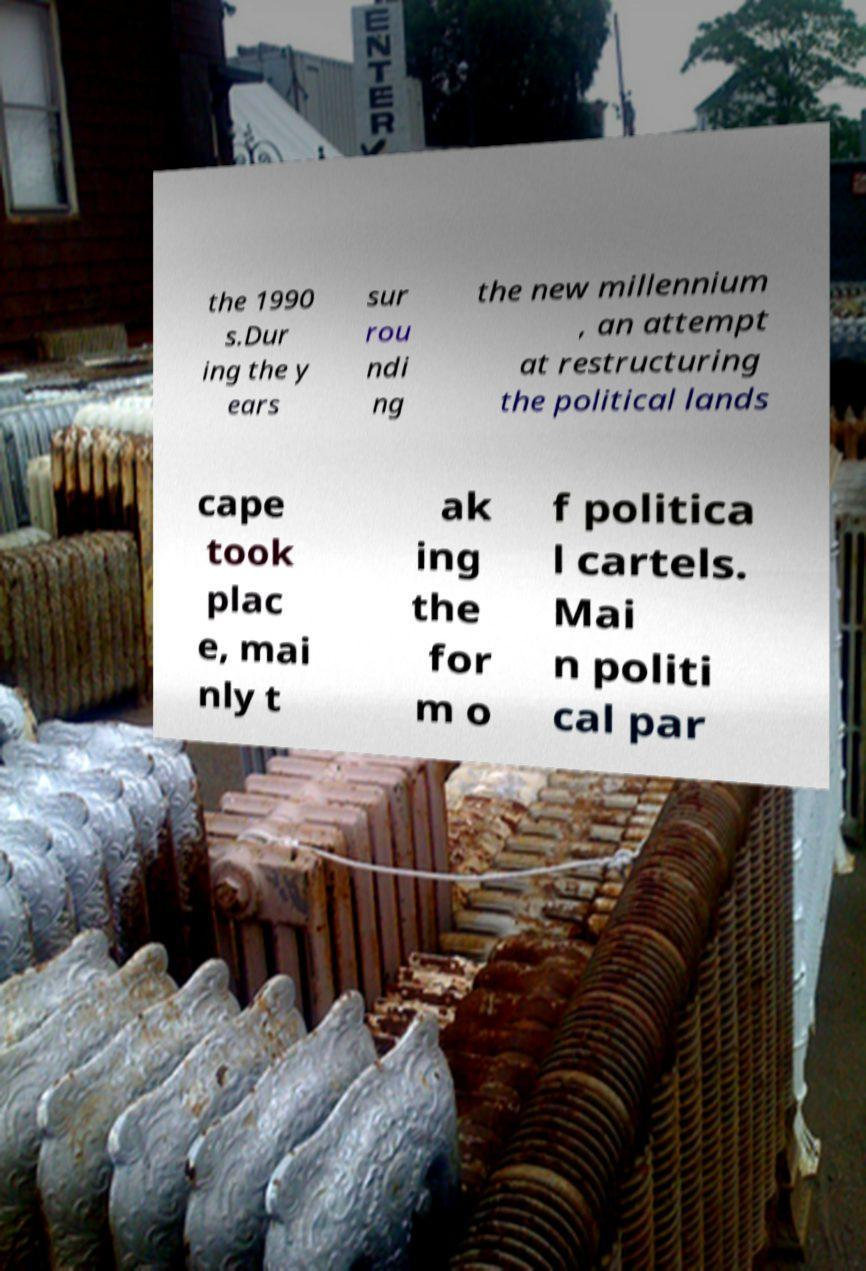Could you extract and type out the text from this image? the 1990 s.Dur ing the y ears sur rou ndi ng the new millennium , an attempt at restructuring the political lands cape took plac e, mai nly t ak ing the for m o f politica l cartels. Mai n politi cal par 